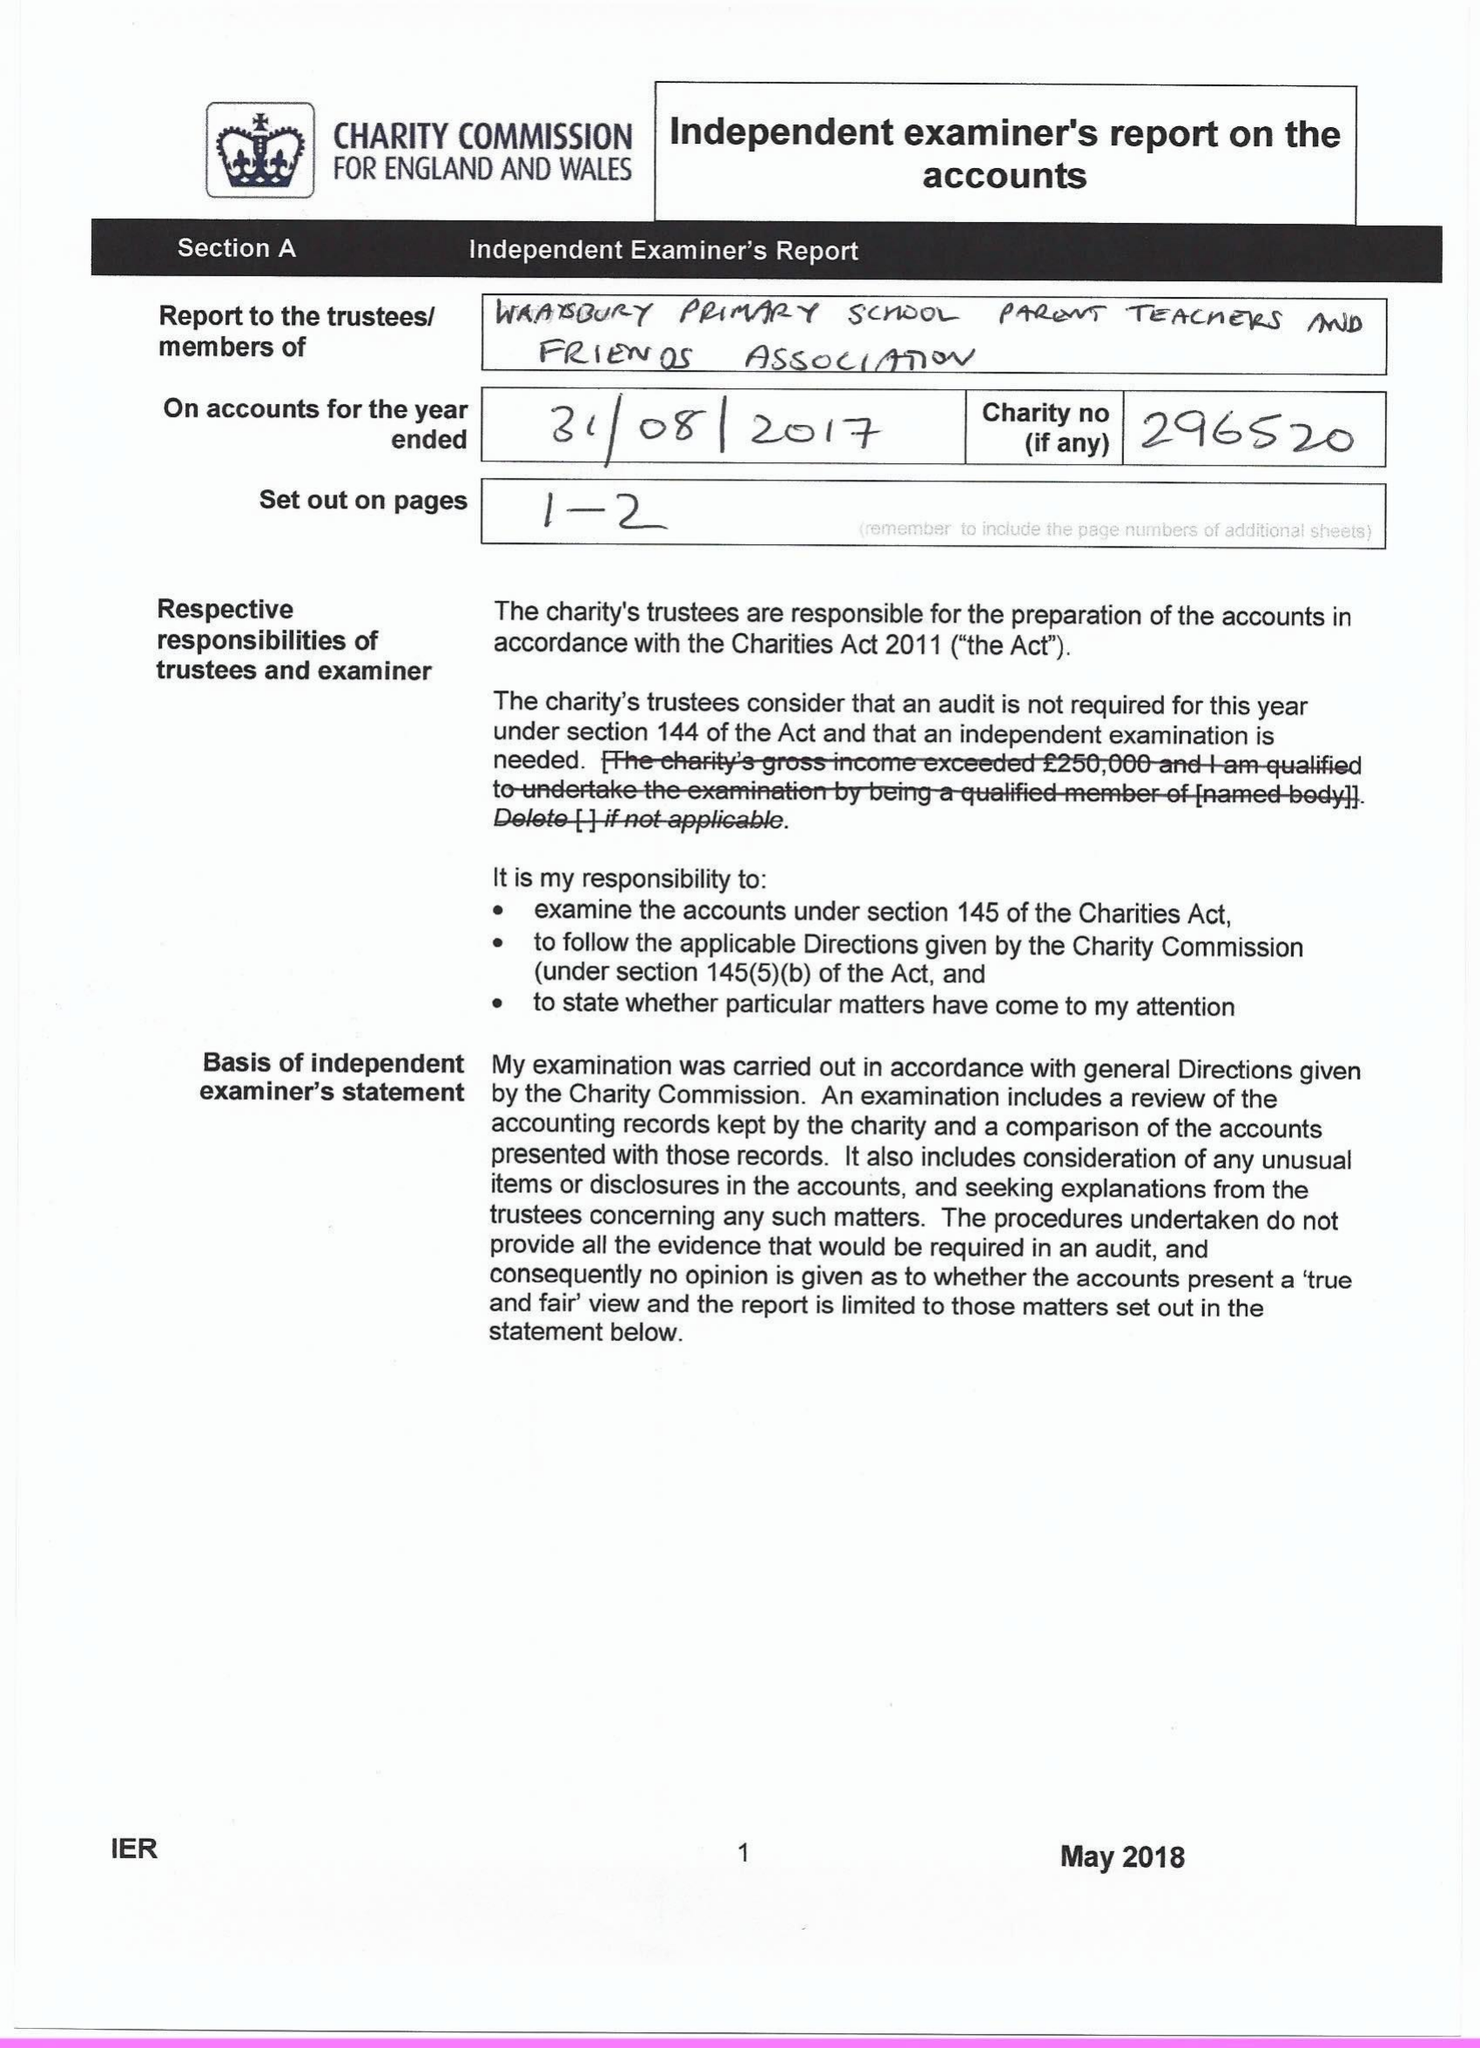What is the value for the charity_name?
Answer the question using a single word or phrase. Wraysbury School Parent Teachers and Friends Association 